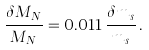Convert formula to latex. <formula><loc_0><loc_0><loc_500><loc_500>\frac { \delta M _ { N } } { M _ { N } } = 0 . 0 1 1 \, \frac { \delta m _ { s } } { m _ { s } } \, .</formula> 